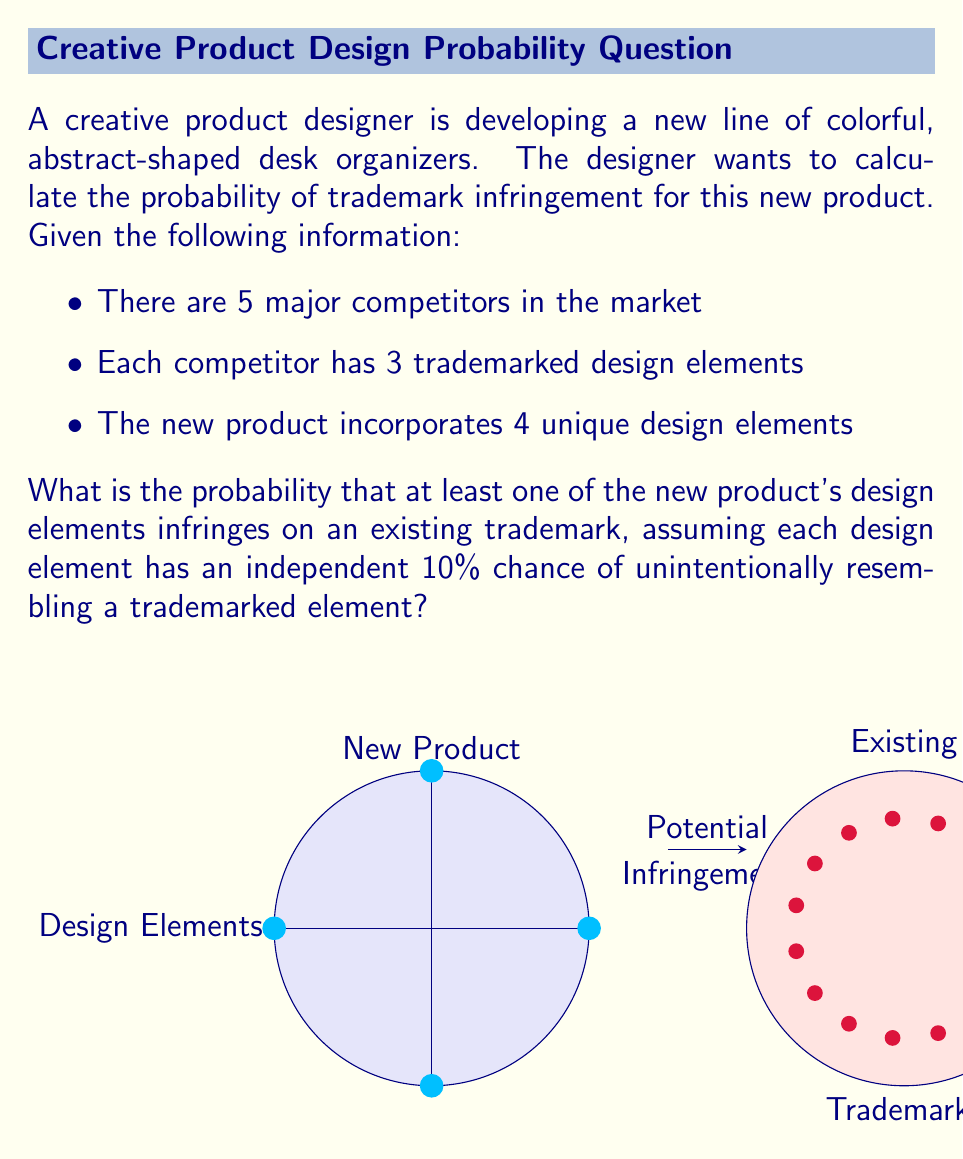Help me with this question. Let's approach this step-by-step:

1) First, we need to calculate the probability that a single design element does not infringe on any existing trademark:

   $P(\text{no infringement for one element}) = (1 - 0.10)^{5 \times 3} = 0.9^{15} \approx 0.2059$

   This is because there are 5 competitors, each with 3 trademarked elements, and the chance of not infringing on each is 90% (1 - 10%).

2) Now, for the entire product to not infringe, all 4 of its design elements must not infringe:

   $P(\text{no infringement for product}) = (0.2059)^4 \approx 0.0018$

3) Therefore, the probability of at least one infringement is the complement of this:

   $P(\text{at least one infringement}) = 1 - P(\text{no infringement for product})$
   $= 1 - 0.0018 \approx 0.9982$

4) We can verify this using the binomial probability formula:

   $P(\text{at least one infringement}) = 1 - \binom{4}{0}p^0(1-p)^4$

   Where $p = 1 - 0.9^{15}$ is the probability of a single element infringing.

   This gives us the same result: $\approx 0.9982$
Answer: $0.9982$ or $99.82\%$ 